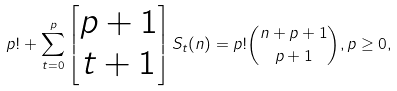<formula> <loc_0><loc_0><loc_500><loc_500>p ! + \sum _ { t = 0 } ^ { p } \begin{bmatrix} p + 1 \\ t + 1 \end{bmatrix} S _ { t } ( n ) = p ! \binom { n + p + 1 } { p + 1 } , p \geq 0 ,</formula> 